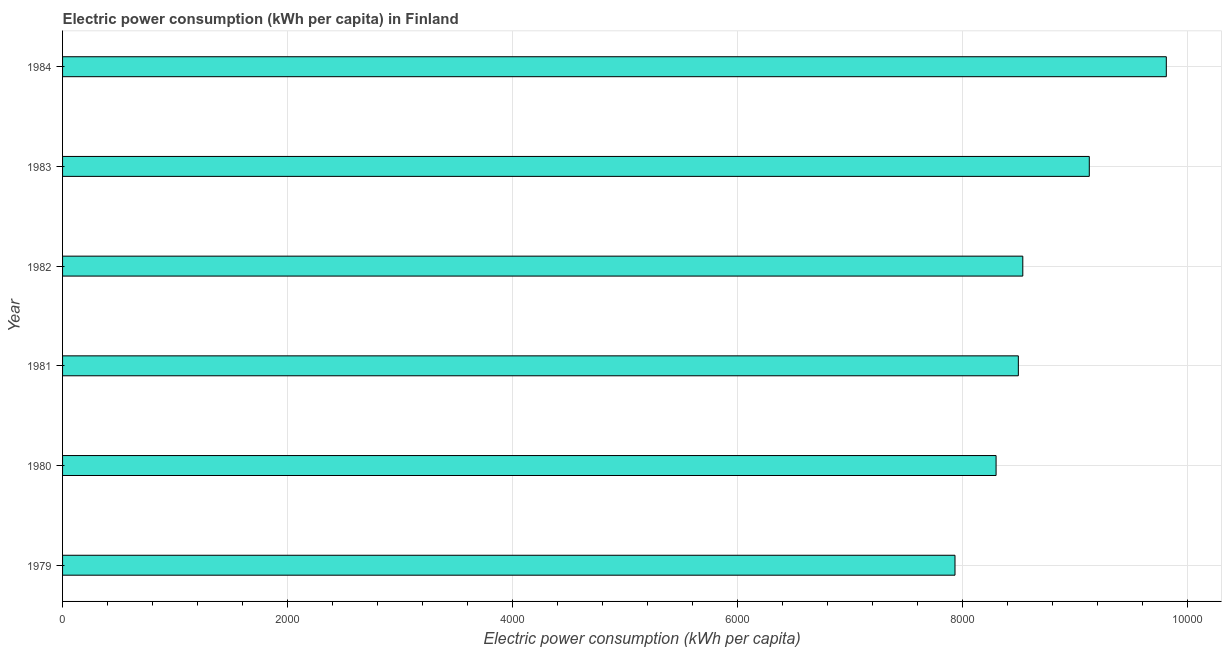Does the graph contain grids?
Your response must be concise. Yes. What is the title of the graph?
Ensure brevity in your answer.  Electric power consumption (kWh per capita) in Finland. What is the label or title of the X-axis?
Provide a succinct answer. Electric power consumption (kWh per capita). What is the label or title of the Y-axis?
Ensure brevity in your answer.  Year. What is the electric power consumption in 1983?
Provide a succinct answer. 9124.16. Across all years, what is the maximum electric power consumption?
Keep it short and to the point. 9808.47. Across all years, what is the minimum electric power consumption?
Make the answer very short. 7930.63. In which year was the electric power consumption maximum?
Your response must be concise. 1984. In which year was the electric power consumption minimum?
Make the answer very short. 1979. What is the sum of the electric power consumption?
Your response must be concise. 5.22e+04. What is the difference between the electric power consumption in 1980 and 1981?
Offer a very short reply. -197.82. What is the average electric power consumption per year?
Your response must be concise. 8697.64. What is the median electric power consumption?
Give a very brief answer. 8513.38. Do a majority of the years between 1982 and 1981 (inclusive) have electric power consumption greater than 800 kWh per capita?
Your response must be concise. No. Is the electric power consumption in 1982 less than that in 1983?
Ensure brevity in your answer.  Yes. What is the difference between the highest and the second highest electric power consumption?
Make the answer very short. 684.3. Is the sum of the electric power consumption in 1979 and 1984 greater than the maximum electric power consumption across all years?
Your response must be concise. Yes. What is the difference between the highest and the lowest electric power consumption?
Provide a short and direct response. 1877.83. In how many years, is the electric power consumption greater than the average electric power consumption taken over all years?
Your answer should be compact. 2. Are all the bars in the graph horizontal?
Make the answer very short. Yes. What is the difference between two consecutive major ticks on the X-axis?
Offer a very short reply. 2000. Are the values on the major ticks of X-axis written in scientific E-notation?
Provide a short and direct response. No. What is the Electric power consumption (kWh per capita) of 1979?
Give a very brief answer. 7930.63. What is the Electric power consumption (kWh per capita) in 1980?
Make the answer very short. 8295.79. What is the Electric power consumption (kWh per capita) of 1981?
Offer a very short reply. 8493.61. What is the Electric power consumption (kWh per capita) of 1982?
Provide a succinct answer. 8533.16. What is the Electric power consumption (kWh per capita) of 1983?
Make the answer very short. 9124.16. What is the Electric power consumption (kWh per capita) of 1984?
Keep it short and to the point. 9808.47. What is the difference between the Electric power consumption (kWh per capita) in 1979 and 1980?
Provide a succinct answer. -365.15. What is the difference between the Electric power consumption (kWh per capita) in 1979 and 1981?
Keep it short and to the point. -562.97. What is the difference between the Electric power consumption (kWh per capita) in 1979 and 1982?
Provide a succinct answer. -602.53. What is the difference between the Electric power consumption (kWh per capita) in 1979 and 1983?
Make the answer very short. -1193.53. What is the difference between the Electric power consumption (kWh per capita) in 1979 and 1984?
Your answer should be compact. -1877.83. What is the difference between the Electric power consumption (kWh per capita) in 1980 and 1981?
Give a very brief answer. -197.82. What is the difference between the Electric power consumption (kWh per capita) in 1980 and 1982?
Offer a terse response. -237.38. What is the difference between the Electric power consumption (kWh per capita) in 1980 and 1983?
Your response must be concise. -828.38. What is the difference between the Electric power consumption (kWh per capita) in 1980 and 1984?
Keep it short and to the point. -1512.68. What is the difference between the Electric power consumption (kWh per capita) in 1981 and 1982?
Provide a short and direct response. -39.56. What is the difference between the Electric power consumption (kWh per capita) in 1981 and 1983?
Your response must be concise. -630.56. What is the difference between the Electric power consumption (kWh per capita) in 1981 and 1984?
Your answer should be compact. -1314.86. What is the difference between the Electric power consumption (kWh per capita) in 1982 and 1983?
Keep it short and to the point. -591. What is the difference between the Electric power consumption (kWh per capita) in 1982 and 1984?
Provide a succinct answer. -1275.3. What is the difference between the Electric power consumption (kWh per capita) in 1983 and 1984?
Make the answer very short. -684.3. What is the ratio of the Electric power consumption (kWh per capita) in 1979 to that in 1980?
Your answer should be compact. 0.96. What is the ratio of the Electric power consumption (kWh per capita) in 1979 to that in 1981?
Your answer should be compact. 0.93. What is the ratio of the Electric power consumption (kWh per capita) in 1979 to that in 1982?
Give a very brief answer. 0.93. What is the ratio of the Electric power consumption (kWh per capita) in 1979 to that in 1983?
Ensure brevity in your answer.  0.87. What is the ratio of the Electric power consumption (kWh per capita) in 1979 to that in 1984?
Ensure brevity in your answer.  0.81. What is the ratio of the Electric power consumption (kWh per capita) in 1980 to that in 1981?
Offer a very short reply. 0.98. What is the ratio of the Electric power consumption (kWh per capita) in 1980 to that in 1982?
Provide a short and direct response. 0.97. What is the ratio of the Electric power consumption (kWh per capita) in 1980 to that in 1983?
Offer a terse response. 0.91. What is the ratio of the Electric power consumption (kWh per capita) in 1980 to that in 1984?
Give a very brief answer. 0.85. What is the ratio of the Electric power consumption (kWh per capita) in 1981 to that in 1982?
Your answer should be very brief. 0.99. What is the ratio of the Electric power consumption (kWh per capita) in 1981 to that in 1983?
Keep it short and to the point. 0.93. What is the ratio of the Electric power consumption (kWh per capita) in 1981 to that in 1984?
Provide a short and direct response. 0.87. What is the ratio of the Electric power consumption (kWh per capita) in 1982 to that in 1983?
Offer a very short reply. 0.94. What is the ratio of the Electric power consumption (kWh per capita) in 1982 to that in 1984?
Keep it short and to the point. 0.87. What is the ratio of the Electric power consumption (kWh per capita) in 1983 to that in 1984?
Offer a very short reply. 0.93. 